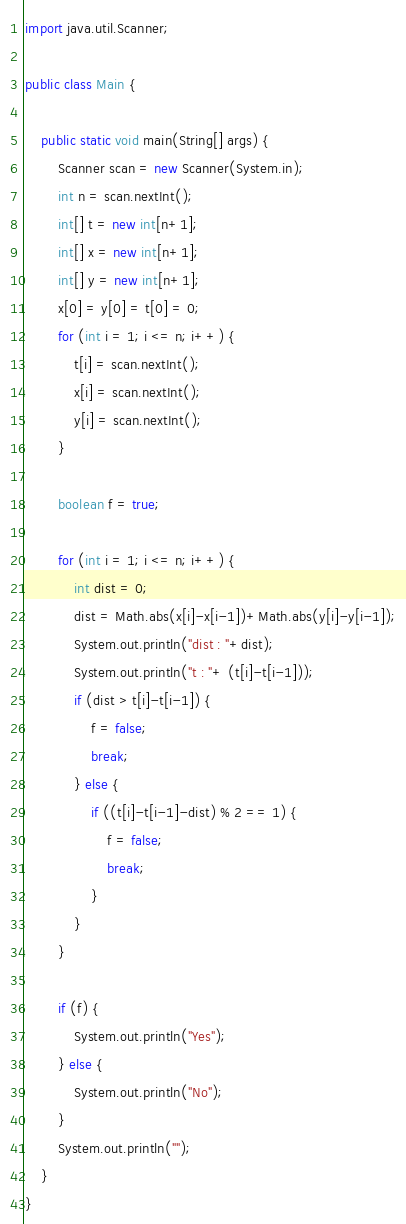Convert code to text. <code><loc_0><loc_0><loc_500><loc_500><_Java_>import java.util.Scanner;

public class Main {

	public static void main(String[] args) {
		Scanner scan = new Scanner(System.in);
		int n = scan.nextInt();
		int[] t = new int[n+1];
		int[] x = new int[n+1];
		int[] y = new int[n+1];
		x[0] = y[0] = t[0] = 0;
		for (int i = 1; i <= n; i++) {
			t[i] = scan.nextInt();
			x[i] = scan.nextInt();
			y[i] = scan.nextInt();
		}

		boolean f = true;

		for (int i = 1; i <= n; i++) {
			int dist = 0;
			dist = Math.abs(x[i]-x[i-1])+Math.abs(y[i]-y[i-1]);
			System.out.println("dist : "+dist);
			System.out.println("t : "+ (t[i]-t[i-1]));
			if (dist > t[i]-t[i-1]) {
				f = false;
				break;
			} else {
				if ((t[i]-t[i-1]-dist) % 2 == 1) {
					f = false;
					break;
				}
			}
		}

		if (f) {
			System.out.println("Yes");
		} else {
			System.out.println("No");
		}
		System.out.println("");
	}
}
</code> 